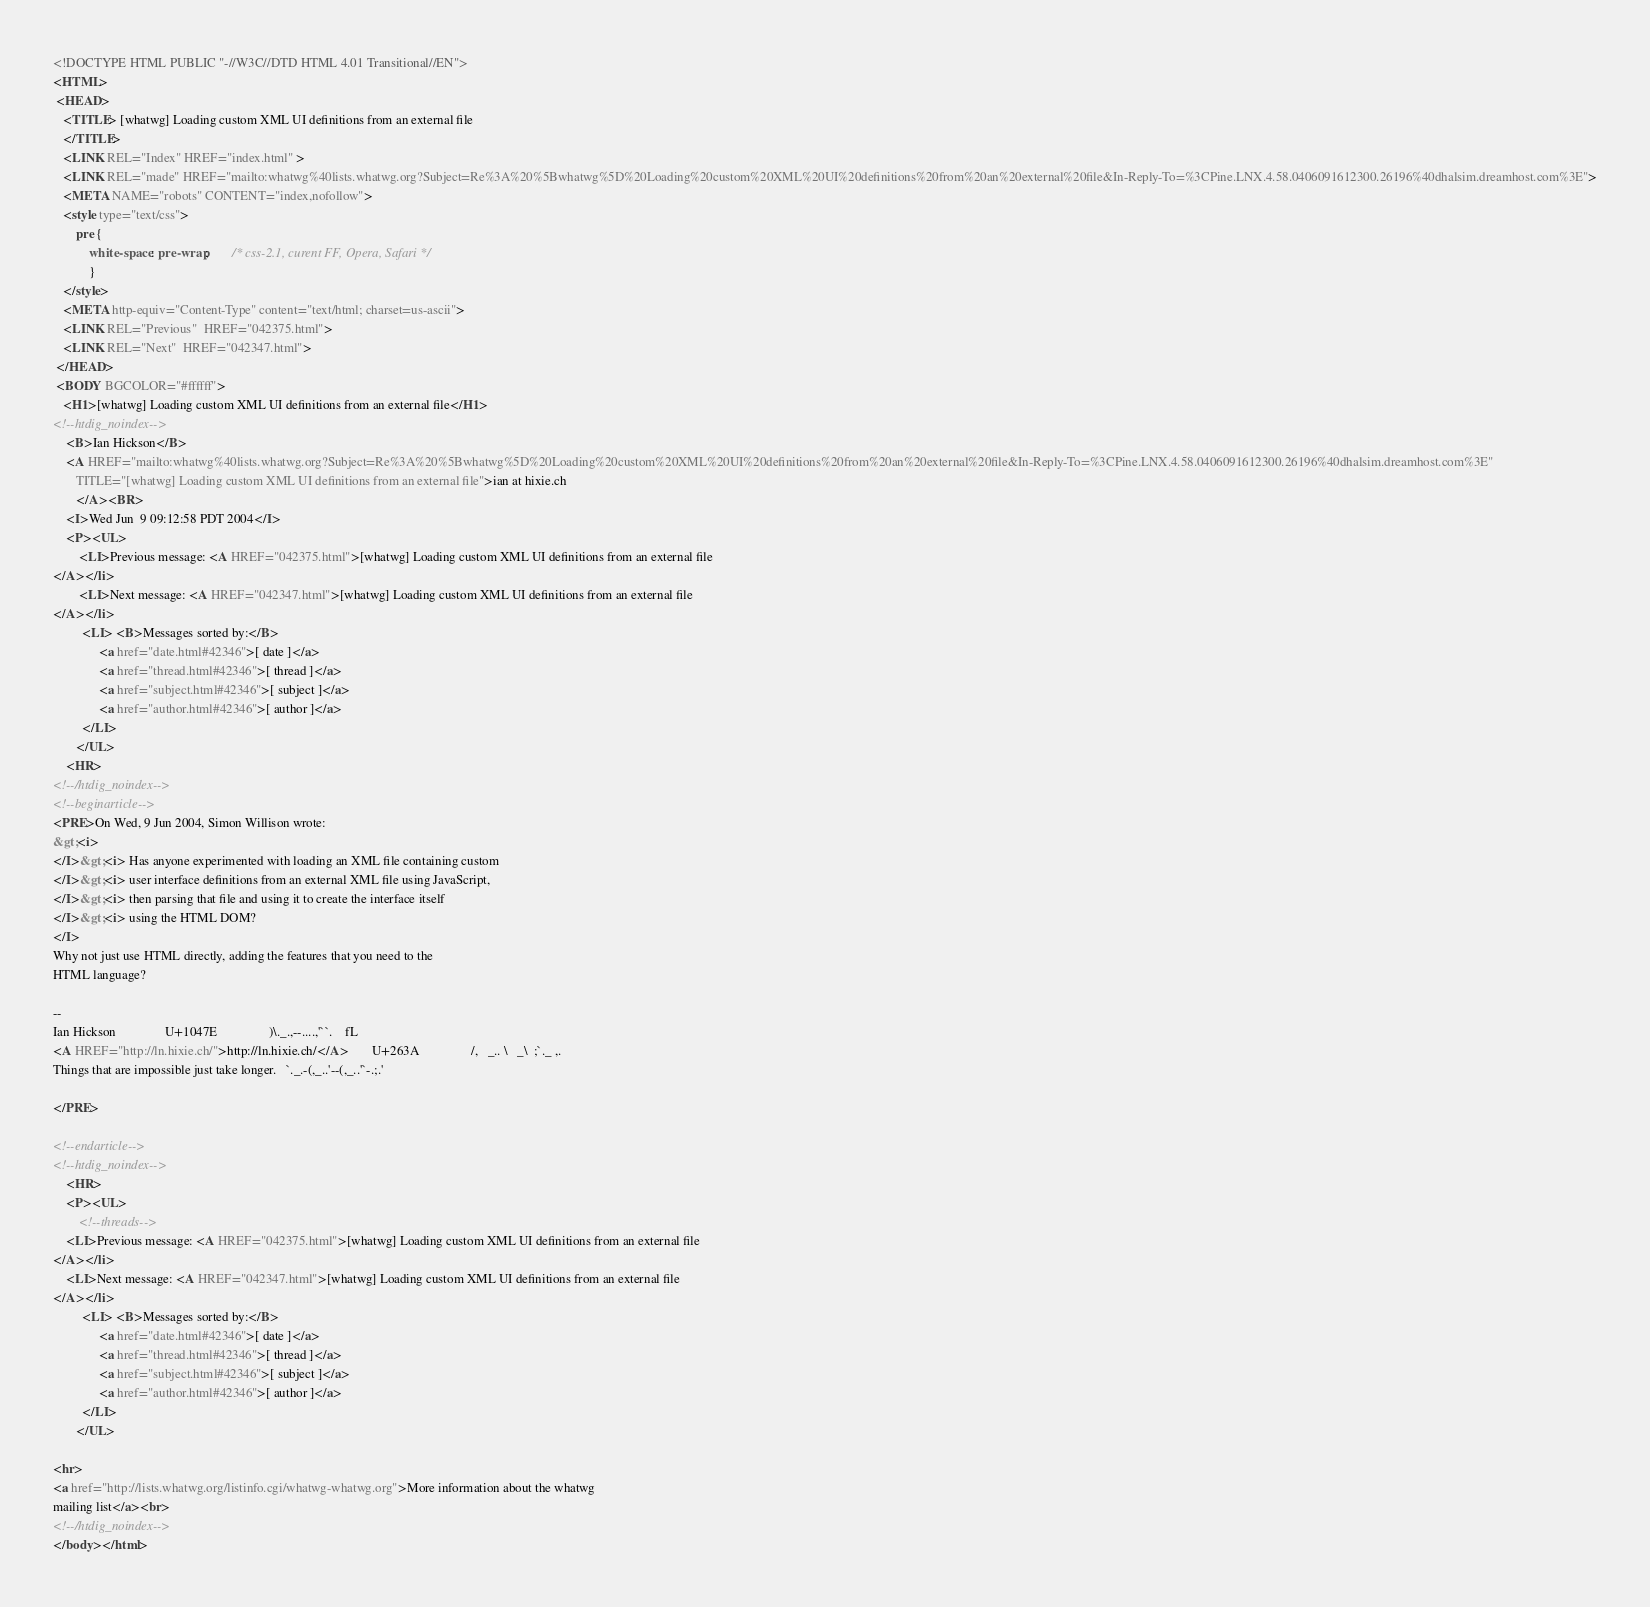Convert code to text. <code><loc_0><loc_0><loc_500><loc_500><_HTML_><!DOCTYPE HTML PUBLIC "-//W3C//DTD HTML 4.01 Transitional//EN">
<HTML>
 <HEAD>
   <TITLE> [whatwg] Loading custom XML UI definitions from an external file
   </TITLE>
   <LINK REL="Index" HREF="index.html" >
   <LINK REL="made" HREF="mailto:whatwg%40lists.whatwg.org?Subject=Re%3A%20%5Bwhatwg%5D%20Loading%20custom%20XML%20UI%20definitions%20from%20an%20external%20file&In-Reply-To=%3CPine.LNX.4.58.0406091612300.26196%40dhalsim.dreamhost.com%3E">
   <META NAME="robots" CONTENT="index,nofollow">
   <style type="text/css">
       pre {
           white-space: pre-wrap;       /* css-2.1, curent FF, Opera, Safari */
           }
   </style>
   <META http-equiv="Content-Type" content="text/html; charset=us-ascii">
   <LINK REL="Previous"  HREF="042375.html">
   <LINK REL="Next"  HREF="042347.html">
 </HEAD>
 <BODY BGCOLOR="#ffffff">
   <H1>[whatwg] Loading custom XML UI definitions from an external file</H1>
<!--htdig_noindex-->
    <B>Ian Hickson</B> 
    <A HREF="mailto:whatwg%40lists.whatwg.org?Subject=Re%3A%20%5Bwhatwg%5D%20Loading%20custom%20XML%20UI%20definitions%20from%20an%20external%20file&In-Reply-To=%3CPine.LNX.4.58.0406091612300.26196%40dhalsim.dreamhost.com%3E"
       TITLE="[whatwg] Loading custom XML UI definitions from an external file">ian at hixie.ch
       </A><BR>
    <I>Wed Jun  9 09:12:58 PDT 2004</I>
    <P><UL>
        <LI>Previous message: <A HREF="042375.html">[whatwg] Loading custom XML UI definitions from an external file
</A></li>
        <LI>Next message: <A HREF="042347.html">[whatwg] Loading custom XML UI definitions from an external file
</A></li>
         <LI> <B>Messages sorted by:</B> 
              <a href="date.html#42346">[ date ]</a>
              <a href="thread.html#42346">[ thread ]</a>
              <a href="subject.html#42346">[ subject ]</a>
              <a href="author.html#42346">[ author ]</a>
         </LI>
       </UL>
    <HR>  
<!--/htdig_noindex-->
<!--beginarticle-->
<PRE>On Wed, 9 Jun 2004, Simon Willison wrote:
&gt;<i>
</I>&gt;<i> Has anyone experimented with loading an XML file containing custom
</I>&gt;<i> user interface definitions from an external XML file using JavaScript,
</I>&gt;<i> then parsing that file and using it to create the interface itself
</I>&gt;<i> using the HTML DOM?
</I>
Why not just use HTML directly, adding the features that you need to the
HTML language?

-- 
Ian Hickson               U+1047E                )\._.,--....,'``.    fL
<A HREF="http://ln.hixie.ch/">http://ln.hixie.ch/</A>       U+263A                /,   _.. \   _\  ;`._ ,.
Things that are impossible just take longer.   `._.-(,_..'--(,_..'`-.;.'

</PRE>

<!--endarticle-->
<!--htdig_noindex-->
    <HR>
    <P><UL>
        <!--threads-->
	<LI>Previous message: <A HREF="042375.html">[whatwg] Loading custom XML UI definitions from an external file
</A></li>
	<LI>Next message: <A HREF="042347.html">[whatwg] Loading custom XML UI definitions from an external file
</A></li>
         <LI> <B>Messages sorted by:</B> 
              <a href="date.html#42346">[ date ]</a>
              <a href="thread.html#42346">[ thread ]</a>
              <a href="subject.html#42346">[ subject ]</a>
              <a href="author.html#42346">[ author ]</a>
         </LI>
       </UL>

<hr>
<a href="http://lists.whatwg.org/listinfo.cgi/whatwg-whatwg.org">More information about the whatwg
mailing list</a><br>
<!--/htdig_noindex-->
</body></html>
</code> 